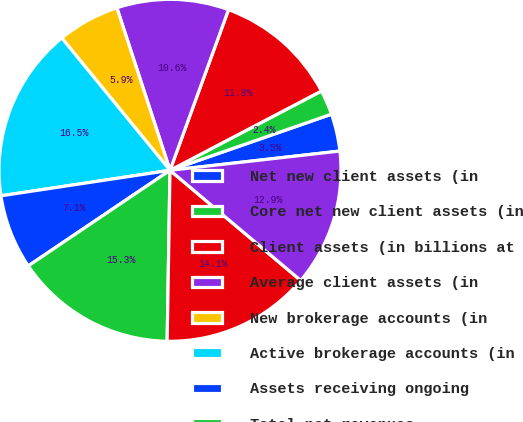<chart> <loc_0><loc_0><loc_500><loc_500><pie_chart><fcel>Net new client assets (in<fcel>Core net new client assets (in<fcel>Client assets (in billions at<fcel>Average client assets (in<fcel>New brokerage accounts (in<fcel>Active brokerage accounts (in<fcel>Assets receiving ongoing<fcel>Total net revenues<fcel>Total expenses excluding<fcel>Income before taxes on income<nl><fcel>3.53%<fcel>2.35%<fcel>11.76%<fcel>10.59%<fcel>5.88%<fcel>16.47%<fcel>7.06%<fcel>15.29%<fcel>14.12%<fcel>12.94%<nl></chart> 